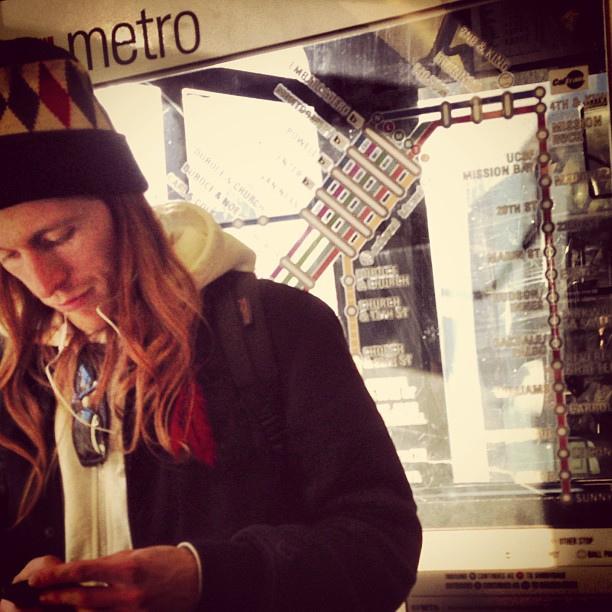Does this man have sunglasses with him?
Answer briefly. Yes. Is the man's hair cut short?
Give a very brief answer. No. Is the man wearing a hat?
Answer briefly. Yes. 